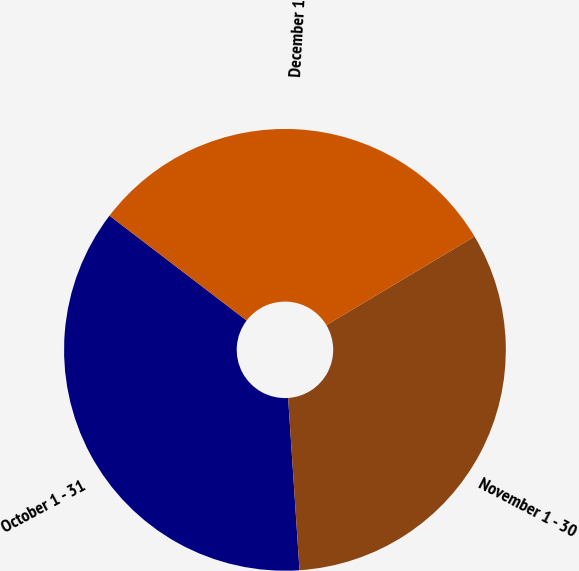Convert chart to OTSL. <chart><loc_0><loc_0><loc_500><loc_500><pie_chart><fcel>October 1 - 31<fcel>November 1 - 30<fcel>December 1 - 31<nl><fcel>36.44%<fcel>32.52%<fcel>31.04%<nl></chart> 